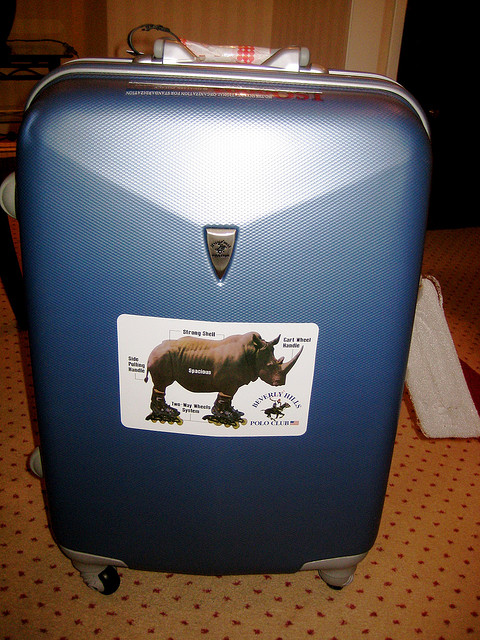Extract all visible text content from this image. POLO CART SYSTEM 